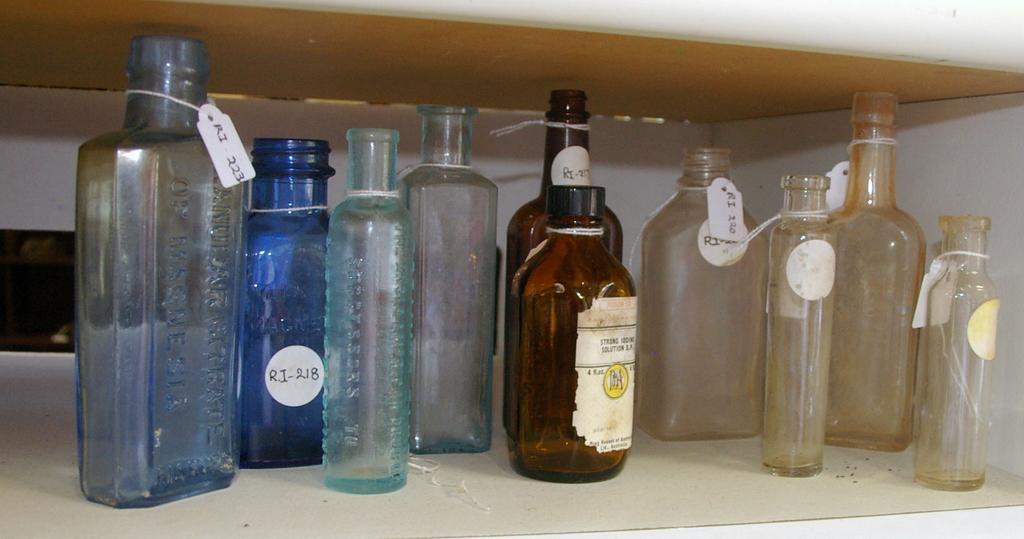In one or two sentences, can you explain what this image depicts? In this image I see lot of bottles. 